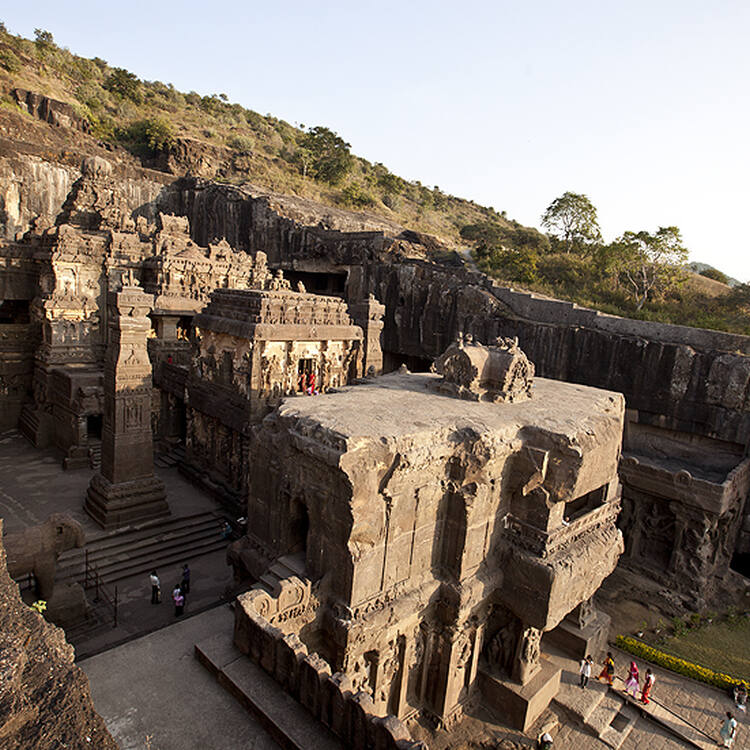Describe a typical day in Ellora Caves during its peak utilization period. During its peak utilization period, the Ellora Caves would have been a bustling hub of religious activity, craftsmanship, and scholarly pursuits. Monks, artisans, and traders would traverse the pathways, engaging in rituals, teachings, and trade. The air would resonate with the chants of prayers and the sound of chisels carving intricate designs into the rock. Pilgrims from distant lands would visit the caves to offer their respects and seek spiritual enlightenment. Markets would thrive outside the caves, providing goods and essentials to the inhabitants and visitors. The day would end with the setting sun casting a golden hue over the carved facades, marking the completion of another day in the vibrant and holy site. 